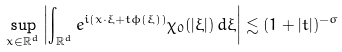<formula> <loc_0><loc_0><loc_500><loc_500>\sup _ { x \in \mathbb { R } ^ { d } } \left | \int _ { \mathbb { R } ^ { d } } e ^ { i ( x \cdot \xi + t \phi ( \xi ) ) } \chi _ { 0 } ( | \xi | ) \, d \xi \right | \lesssim ( 1 + | t | ) ^ { - \sigma }</formula> 